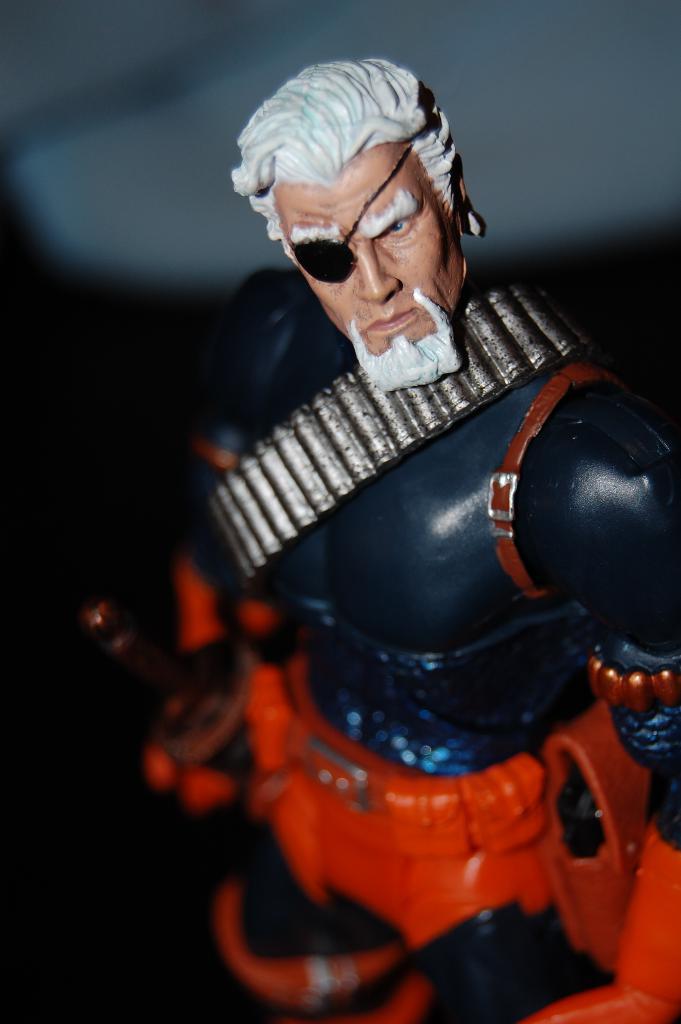How would you summarize this image in a sentence or two? In this image we can see a toy. In the background the image is not clear to describe. 